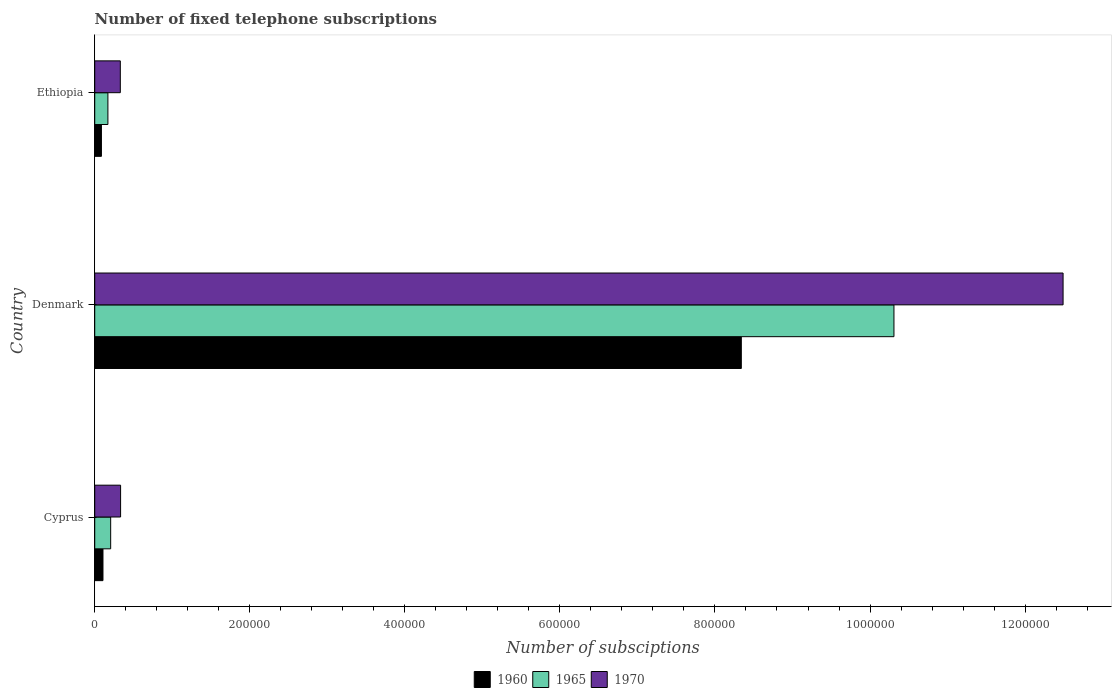How many groups of bars are there?
Provide a succinct answer. 3. Are the number of bars on each tick of the Y-axis equal?
Offer a very short reply. Yes. How many bars are there on the 3rd tick from the bottom?
Offer a terse response. 3. What is the label of the 1st group of bars from the top?
Ensure brevity in your answer.  Ethiopia. In how many cases, is the number of bars for a given country not equal to the number of legend labels?
Your response must be concise. 0. What is the number of fixed telephone subscriptions in 1970 in Ethiopia?
Provide a short and direct response. 3.30e+04. Across all countries, what is the maximum number of fixed telephone subscriptions in 1965?
Give a very brief answer. 1.03e+06. Across all countries, what is the minimum number of fixed telephone subscriptions in 1960?
Provide a succinct answer. 8636. In which country was the number of fixed telephone subscriptions in 1970 minimum?
Provide a succinct answer. Ethiopia. What is the total number of fixed telephone subscriptions in 1965 in the graph?
Your answer should be compact. 1.07e+06. What is the difference between the number of fixed telephone subscriptions in 1960 in Cyprus and that in Ethiopia?
Make the answer very short. 1994. What is the difference between the number of fixed telephone subscriptions in 1965 in Denmark and the number of fixed telephone subscriptions in 1970 in Cyprus?
Your response must be concise. 9.98e+05. What is the average number of fixed telephone subscriptions in 1960 per country?
Ensure brevity in your answer.  2.84e+05. What is the difference between the number of fixed telephone subscriptions in 1970 and number of fixed telephone subscriptions in 1965 in Ethiopia?
Your answer should be compact. 1.60e+04. In how many countries, is the number of fixed telephone subscriptions in 1960 greater than 960000 ?
Your answer should be compact. 0. What is the ratio of the number of fixed telephone subscriptions in 1960 in Cyprus to that in Denmark?
Offer a very short reply. 0.01. Is the number of fixed telephone subscriptions in 1960 in Denmark less than that in Ethiopia?
Your response must be concise. No. What is the difference between the highest and the second highest number of fixed telephone subscriptions in 1970?
Provide a short and direct response. 1.22e+06. What is the difference between the highest and the lowest number of fixed telephone subscriptions in 1965?
Make the answer very short. 1.01e+06. What does the 2nd bar from the bottom in Denmark represents?
Provide a short and direct response. 1965. Is it the case that in every country, the sum of the number of fixed telephone subscriptions in 1965 and number of fixed telephone subscriptions in 1970 is greater than the number of fixed telephone subscriptions in 1960?
Offer a terse response. Yes. What is the difference between two consecutive major ticks on the X-axis?
Make the answer very short. 2.00e+05. Are the values on the major ticks of X-axis written in scientific E-notation?
Offer a very short reply. No. Does the graph contain any zero values?
Offer a very short reply. No. What is the title of the graph?
Provide a short and direct response. Number of fixed telephone subscriptions. Does "1993" appear as one of the legend labels in the graph?
Offer a terse response. No. What is the label or title of the X-axis?
Ensure brevity in your answer.  Number of subsciptions. What is the Number of subsciptions of 1960 in Cyprus?
Keep it short and to the point. 1.06e+04. What is the Number of subsciptions in 1965 in Cyprus?
Keep it short and to the point. 2.06e+04. What is the Number of subsciptions of 1970 in Cyprus?
Offer a very short reply. 3.34e+04. What is the Number of subsciptions in 1960 in Denmark?
Provide a succinct answer. 8.34e+05. What is the Number of subsciptions in 1965 in Denmark?
Your answer should be compact. 1.03e+06. What is the Number of subsciptions of 1970 in Denmark?
Offer a very short reply. 1.25e+06. What is the Number of subsciptions of 1960 in Ethiopia?
Give a very brief answer. 8636. What is the Number of subsciptions in 1965 in Ethiopia?
Offer a terse response. 1.70e+04. What is the Number of subsciptions in 1970 in Ethiopia?
Offer a terse response. 3.30e+04. Across all countries, what is the maximum Number of subsciptions in 1960?
Make the answer very short. 8.34e+05. Across all countries, what is the maximum Number of subsciptions of 1965?
Your answer should be very brief. 1.03e+06. Across all countries, what is the maximum Number of subsciptions in 1970?
Provide a succinct answer. 1.25e+06. Across all countries, what is the minimum Number of subsciptions of 1960?
Ensure brevity in your answer.  8636. Across all countries, what is the minimum Number of subsciptions of 1965?
Your answer should be very brief. 1.70e+04. Across all countries, what is the minimum Number of subsciptions of 1970?
Provide a short and direct response. 3.30e+04. What is the total Number of subsciptions in 1960 in the graph?
Offer a terse response. 8.53e+05. What is the total Number of subsciptions in 1965 in the graph?
Your answer should be very brief. 1.07e+06. What is the total Number of subsciptions in 1970 in the graph?
Keep it short and to the point. 1.32e+06. What is the difference between the Number of subsciptions of 1960 in Cyprus and that in Denmark?
Ensure brevity in your answer.  -8.23e+05. What is the difference between the Number of subsciptions of 1965 in Cyprus and that in Denmark?
Provide a succinct answer. -1.01e+06. What is the difference between the Number of subsciptions in 1970 in Cyprus and that in Denmark?
Make the answer very short. -1.22e+06. What is the difference between the Number of subsciptions of 1960 in Cyprus and that in Ethiopia?
Your answer should be very brief. 1994. What is the difference between the Number of subsciptions of 1965 in Cyprus and that in Ethiopia?
Offer a very short reply. 3550. What is the difference between the Number of subsciptions of 1970 in Cyprus and that in Ethiopia?
Provide a succinct answer. 359. What is the difference between the Number of subsciptions in 1960 in Denmark and that in Ethiopia?
Your answer should be very brief. 8.25e+05. What is the difference between the Number of subsciptions of 1965 in Denmark and that in Ethiopia?
Keep it short and to the point. 1.01e+06. What is the difference between the Number of subsciptions in 1970 in Denmark and that in Ethiopia?
Provide a succinct answer. 1.22e+06. What is the difference between the Number of subsciptions in 1960 in Cyprus and the Number of subsciptions in 1965 in Denmark?
Provide a succinct answer. -1.02e+06. What is the difference between the Number of subsciptions of 1960 in Cyprus and the Number of subsciptions of 1970 in Denmark?
Your response must be concise. -1.24e+06. What is the difference between the Number of subsciptions of 1965 in Cyprus and the Number of subsciptions of 1970 in Denmark?
Provide a short and direct response. -1.23e+06. What is the difference between the Number of subsciptions in 1960 in Cyprus and the Number of subsciptions in 1965 in Ethiopia?
Ensure brevity in your answer.  -6370. What is the difference between the Number of subsciptions in 1960 in Cyprus and the Number of subsciptions in 1970 in Ethiopia?
Your answer should be compact. -2.24e+04. What is the difference between the Number of subsciptions in 1965 in Cyprus and the Number of subsciptions in 1970 in Ethiopia?
Ensure brevity in your answer.  -1.24e+04. What is the difference between the Number of subsciptions in 1960 in Denmark and the Number of subsciptions in 1965 in Ethiopia?
Give a very brief answer. 8.17e+05. What is the difference between the Number of subsciptions in 1960 in Denmark and the Number of subsciptions in 1970 in Ethiopia?
Offer a terse response. 8.01e+05. What is the difference between the Number of subsciptions of 1965 in Denmark and the Number of subsciptions of 1970 in Ethiopia?
Make the answer very short. 9.98e+05. What is the average Number of subsciptions of 1960 per country?
Offer a terse response. 2.84e+05. What is the average Number of subsciptions in 1965 per country?
Your answer should be very brief. 3.56e+05. What is the average Number of subsciptions of 1970 per country?
Make the answer very short. 4.38e+05. What is the difference between the Number of subsciptions of 1960 and Number of subsciptions of 1965 in Cyprus?
Offer a terse response. -9920. What is the difference between the Number of subsciptions of 1960 and Number of subsciptions of 1970 in Cyprus?
Make the answer very short. -2.27e+04. What is the difference between the Number of subsciptions of 1965 and Number of subsciptions of 1970 in Cyprus?
Ensure brevity in your answer.  -1.28e+04. What is the difference between the Number of subsciptions in 1960 and Number of subsciptions in 1965 in Denmark?
Provide a succinct answer. -1.97e+05. What is the difference between the Number of subsciptions of 1960 and Number of subsciptions of 1970 in Denmark?
Offer a very short reply. -4.15e+05. What is the difference between the Number of subsciptions in 1965 and Number of subsciptions in 1970 in Denmark?
Ensure brevity in your answer.  -2.18e+05. What is the difference between the Number of subsciptions of 1960 and Number of subsciptions of 1965 in Ethiopia?
Provide a short and direct response. -8364. What is the difference between the Number of subsciptions of 1960 and Number of subsciptions of 1970 in Ethiopia?
Give a very brief answer. -2.44e+04. What is the difference between the Number of subsciptions in 1965 and Number of subsciptions in 1970 in Ethiopia?
Make the answer very short. -1.60e+04. What is the ratio of the Number of subsciptions of 1960 in Cyprus to that in Denmark?
Offer a very short reply. 0.01. What is the ratio of the Number of subsciptions in 1965 in Cyprus to that in Denmark?
Offer a very short reply. 0.02. What is the ratio of the Number of subsciptions in 1970 in Cyprus to that in Denmark?
Offer a very short reply. 0.03. What is the ratio of the Number of subsciptions in 1960 in Cyprus to that in Ethiopia?
Offer a very short reply. 1.23. What is the ratio of the Number of subsciptions in 1965 in Cyprus to that in Ethiopia?
Provide a short and direct response. 1.21. What is the ratio of the Number of subsciptions in 1970 in Cyprus to that in Ethiopia?
Your answer should be very brief. 1.01. What is the ratio of the Number of subsciptions of 1960 in Denmark to that in Ethiopia?
Provide a short and direct response. 96.57. What is the ratio of the Number of subsciptions in 1965 in Denmark to that in Ethiopia?
Your answer should be compact. 60.64. What is the ratio of the Number of subsciptions of 1970 in Denmark to that in Ethiopia?
Make the answer very short. 37.85. What is the difference between the highest and the second highest Number of subsciptions in 1960?
Ensure brevity in your answer.  8.23e+05. What is the difference between the highest and the second highest Number of subsciptions of 1965?
Offer a very short reply. 1.01e+06. What is the difference between the highest and the second highest Number of subsciptions of 1970?
Ensure brevity in your answer.  1.22e+06. What is the difference between the highest and the lowest Number of subsciptions of 1960?
Provide a short and direct response. 8.25e+05. What is the difference between the highest and the lowest Number of subsciptions of 1965?
Provide a succinct answer. 1.01e+06. What is the difference between the highest and the lowest Number of subsciptions in 1970?
Give a very brief answer. 1.22e+06. 